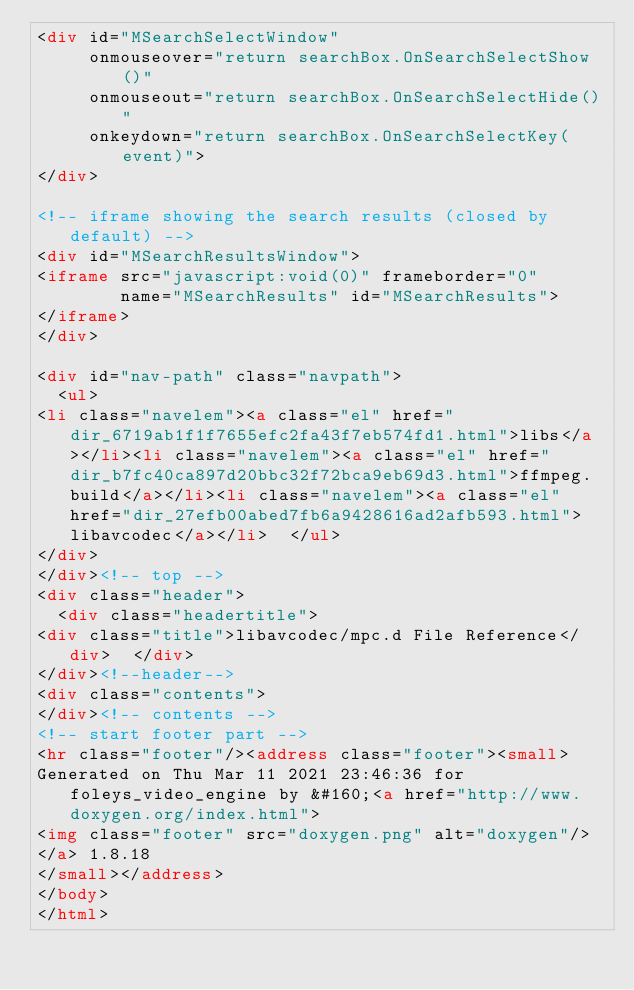Convert code to text. <code><loc_0><loc_0><loc_500><loc_500><_HTML_><div id="MSearchSelectWindow"
     onmouseover="return searchBox.OnSearchSelectShow()"
     onmouseout="return searchBox.OnSearchSelectHide()"
     onkeydown="return searchBox.OnSearchSelectKey(event)">
</div>

<!-- iframe showing the search results (closed by default) -->
<div id="MSearchResultsWindow">
<iframe src="javascript:void(0)" frameborder="0" 
        name="MSearchResults" id="MSearchResults">
</iframe>
</div>

<div id="nav-path" class="navpath">
  <ul>
<li class="navelem"><a class="el" href="dir_6719ab1f1f7655efc2fa43f7eb574fd1.html">libs</a></li><li class="navelem"><a class="el" href="dir_b7fc40ca897d20bbc32f72bca9eb69d3.html">ffmpeg.build</a></li><li class="navelem"><a class="el" href="dir_27efb00abed7fb6a9428616ad2afb593.html">libavcodec</a></li>  </ul>
</div>
</div><!-- top -->
<div class="header">
  <div class="headertitle">
<div class="title">libavcodec/mpc.d File Reference</div>  </div>
</div><!--header-->
<div class="contents">
</div><!-- contents -->
<!-- start footer part -->
<hr class="footer"/><address class="footer"><small>
Generated on Thu Mar 11 2021 23:46:36 for foleys_video_engine by &#160;<a href="http://www.doxygen.org/index.html">
<img class="footer" src="doxygen.png" alt="doxygen"/>
</a> 1.8.18
</small></address>
</body>
</html>
</code> 